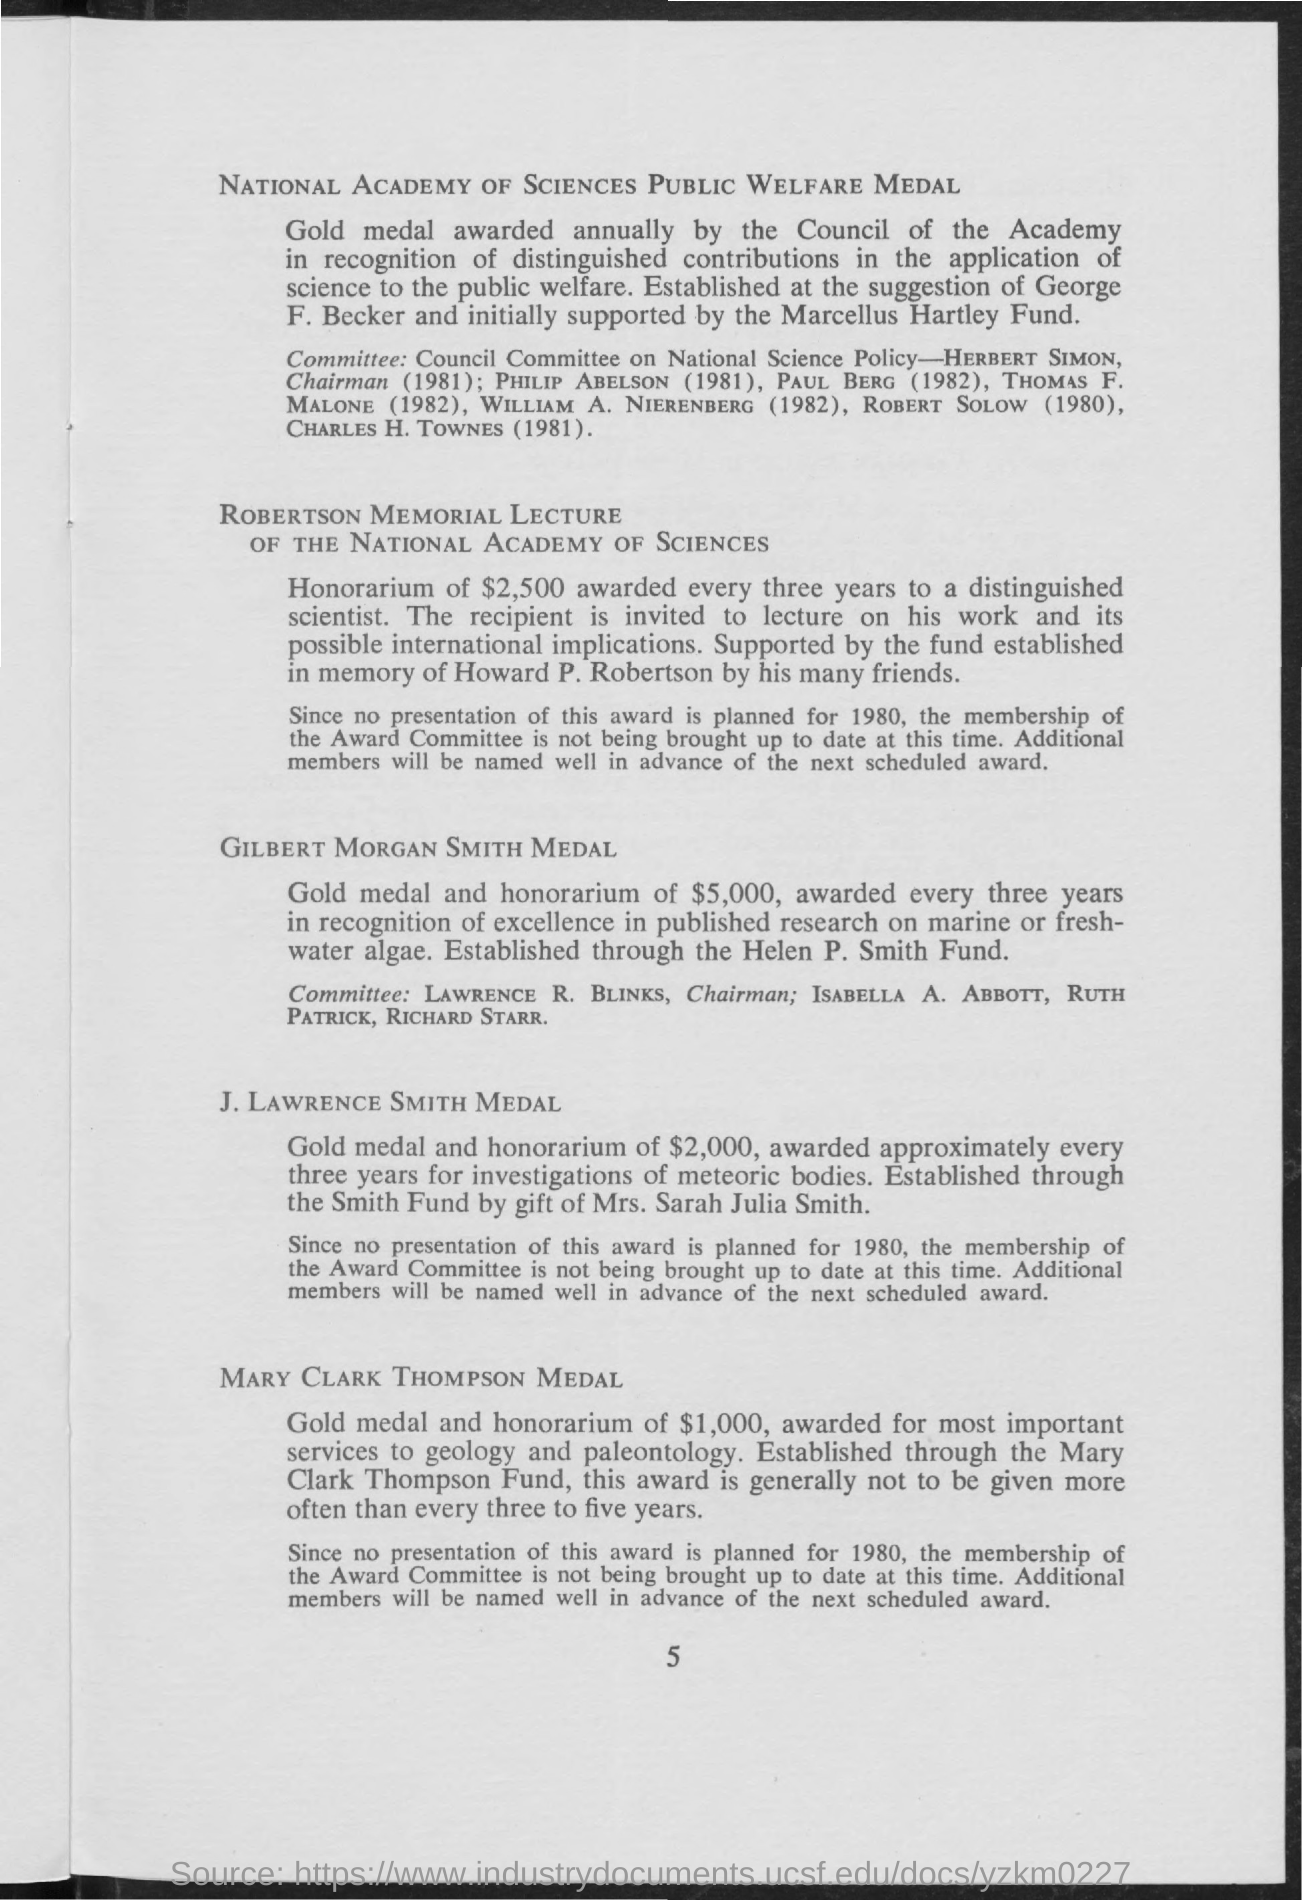Which medal awards gold medal and honorarium of $1,000?
Ensure brevity in your answer.  MARY CLARK THOMPSON MEDAL. Which medal takes into consideration the contributions on marine or fresh-water algae?
Provide a succinct answer. Gilbert morgan smith medal. 